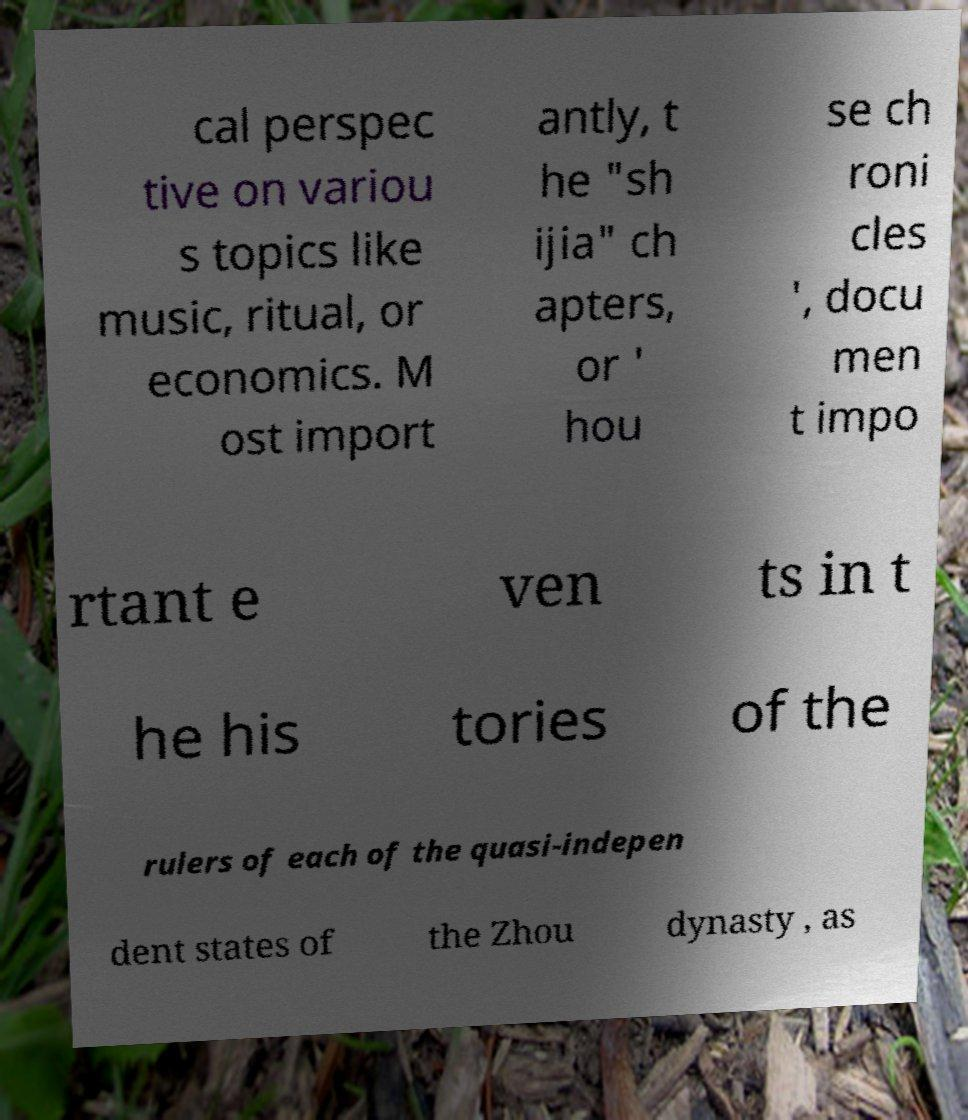For documentation purposes, I need the text within this image transcribed. Could you provide that? cal perspec tive on variou s topics like music, ritual, or economics. M ost import antly, t he "sh ijia" ch apters, or ' hou se ch roni cles ', docu men t impo rtant e ven ts in t he his tories of the rulers of each of the quasi-indepen dent states of the Zhou dynasty , as 